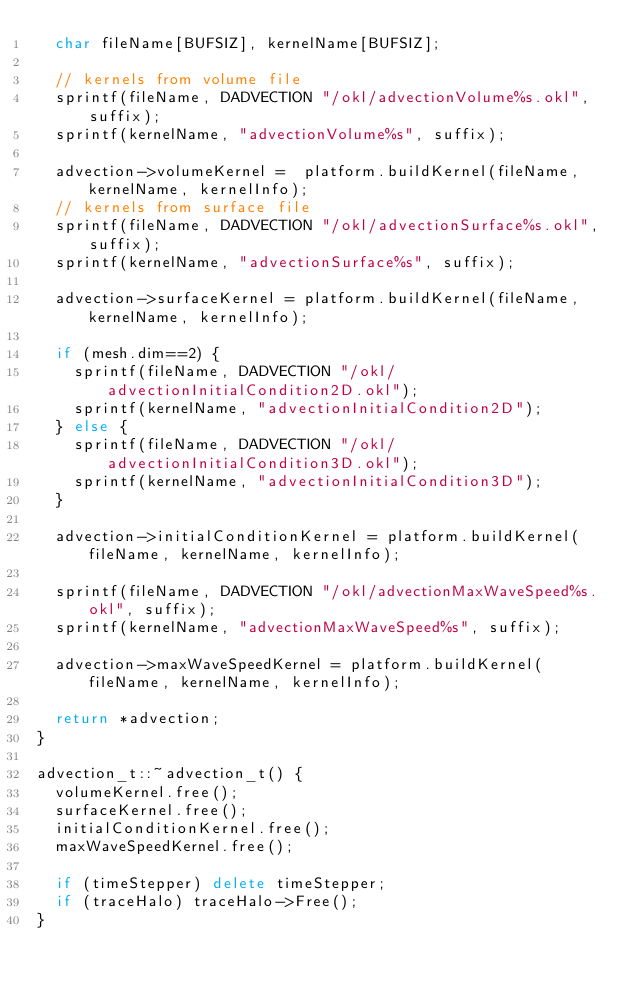<code> <loc_0><loc_0><loc_500><loc_500><_C++_>  char fileName[BUFSIZ], kernelName[BUFSIZ];

  // kernels from volume file
  sprintf(fileName, DADVECTION "/okl/advectionVolume%s.okl", suffix);
  sprintf(kernelName, "advectionVolume%s", suffix);

  advection->volumeKernel =  platform.buildKernel(fileName, kernelName, kernelInfo);
  // kernels from surface file
  sprintf(fileName, DADVECTION "/okl/advectionSurface%s.okl", suffix);
  sprintf(kernelName, "advectionSurface%s", suffix);

  advection->surfaceKernel = platform.buildKernel(fileName, kernelName, kernelInfo);

  if (mesh.dim==2) {
    sprintf(fileName, DADVECTION "/okl/advectionInitialCondition2D.okl");
    sprintf(kernelName, "advectionInitialCondition2D");
  } else {
    sprintf(fileName, DADVECTION "/okl/advectionInitialCondition3D.okl");
    sprintf(kernelName, "advectionInitialCondition3D");
  }

  advection->initialConditionKernel = platform.buildKernel(fileName, kernelName, kernelInfo);

  sprintf(fileName, DADVECTION "/okl/advectionMaxWaveSpeed%s.okl", suffix);
  sprintf(kernelName, "advectionMaxWaveSpeed%s", suffix);

  advection->maxWaveSpeedKernel = platform.buildKernel(fileName, kernelName, kernelInfo);

  return *advection;
}

advection_t::~advection_t() {
  volumeKernel.free();
  surfaceKernel.free();
  initialConditionKernel.free();
  maxWaveSpeedKernel.free();

  if (timeStepper) delete timeStepper;
  if (traceHalo) traceHalo->Free();
}
</code> 